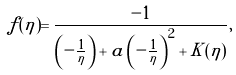Convert formula to latex. <formula><loc_0><loc_0><loc_500><loc_500>\tilde { f } ( \eta ) = \frac { - 1 } { \left ( - \frac { 1 } { \eta } \right ) + a \left ( - \frac { 1 } { \eta } \right ) ^ { 2 } + K ( \eta ) } ,</formula> 